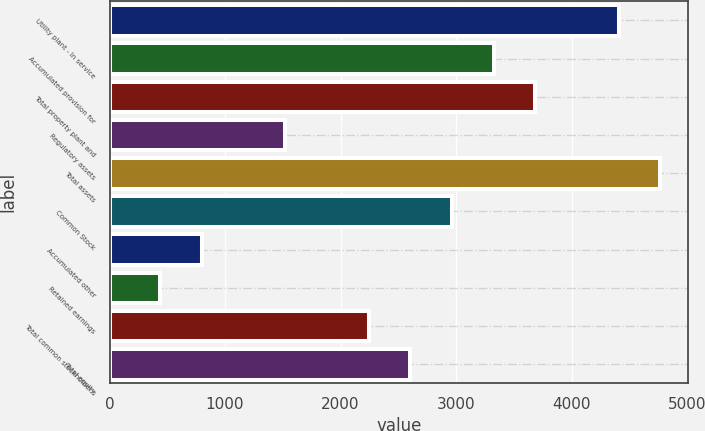Convert chart to OTSL. <chart><loc_0><loc_0><loc_500><loc_500><bar_chart><fcel>Utility plant - In service<fcel>Accumulated provision for<fcel>Total property plant and<fcel>Regulatory assets<fcel>Total assets<fcel>Common Stock<fcel>Accumulated other<fcel>Retained earnings<fcel>Total common stockholder's<fcel>Total equity<nl><fcel>4407.4<fcel>3325.3<fcel>3686<fcel>1521.8<fcel>4768.1<fcel>2964.6<fcel>800.4<fcel>439.7<fcel>2243.2<fcel>2603.9<nl></chart> 